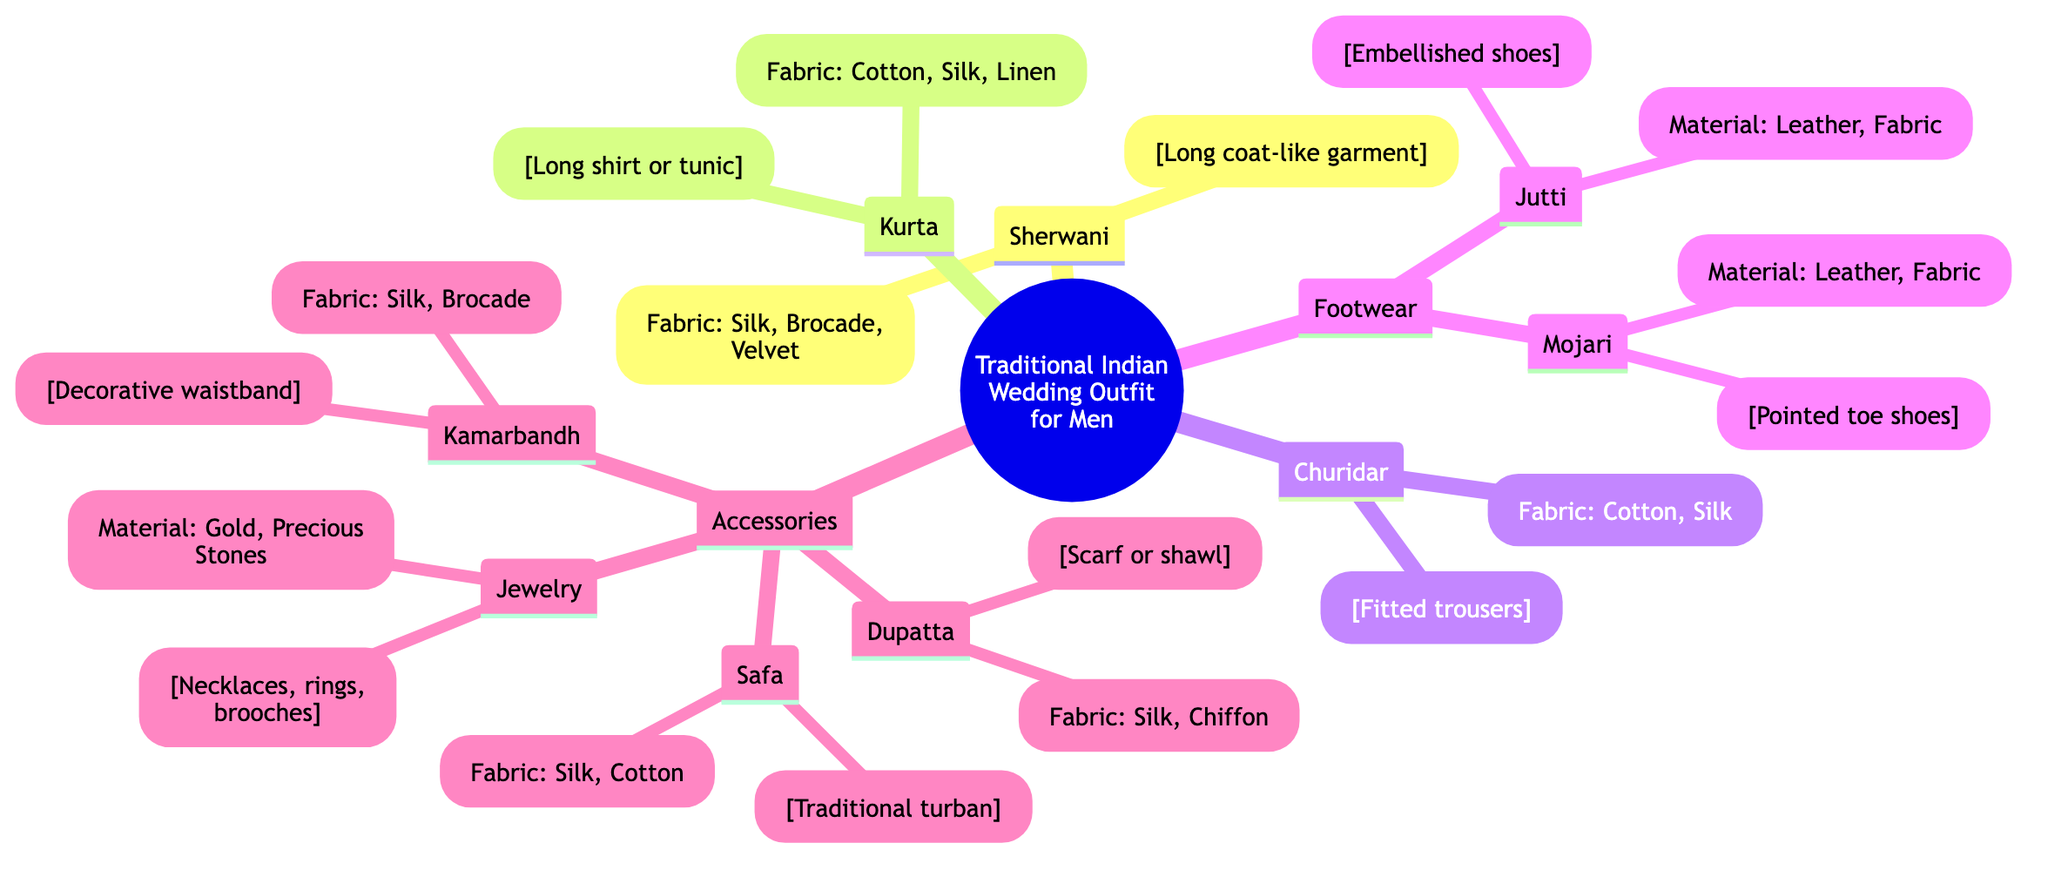What is the primary garment worn in a traditional Indian wedding outfit for men? The diagram identifies the main components of a traditional Indian wedding outfit for men. The first node is "Sherwani," which serves as the primary garment.
Answer: Sherwani How many types of footwear are listed in the diagram? By reviewing the "Footwear" node in the diagram, we can see that there are two types mentioned: "Jutti" and "Mojari." This indicates a total of two types of footwear.
Answer: 2 What fabrics are commonly used for a Sherwani? The "Sherwani" node provides specific fabric options used to make this garment. It lists "Silk, Brocade, Velvet" as the materials.
Answer: Silk, Brocade, Velvet What type of trousers is included in the traditional outfit? In the diagram, the component "Churidar" is directly listed under the traditional attire section, denoting the type of trousers.
Answer: Churidar Which accessory is described as a "traditional turban"? Looking at the "Accessories" section of the diagram, the node labeled "Safa" is identified as a traditional turban, giving us the specific term used to depict this accessory.
Answer: Safa What materials are used for the footwear types mentioned? The "Footwear" section consists of "Jutti" and "Mojari." Each has specific materials listed: for "Jutti," it's "Leather, Fabric," and for "Mojari," it is "Leather, Fabric." Therefore, the combined materials are the same for both: Leather and Fabric.
Answer: Leather, Fabric Which accessory is known for holding the outfit together as a decorative waistband? In the "Accessories" section under the diagram, the term "Kamarbandh" is specifically cited as the decorative waistband, confirming its role in the traditional outfit.
Answer: Kamarbandh What is the common fabric for the Dupatta accessory? The "Dupatta" node makes it clear that it is typically fashioned from "Silk, Chiffon," indicating the materials that are commonly used for this traditional scarf or shawl.
Answer: Silk, Chiffon How many main components are shown in the traditional Indian wedding outfit for men? The primary nodes (or components) displayed directly under the root include "Sherwani," "Kurta," "Churidar," "Footwear," and "Accessories," which are five different main components in total.
Answer: 5 